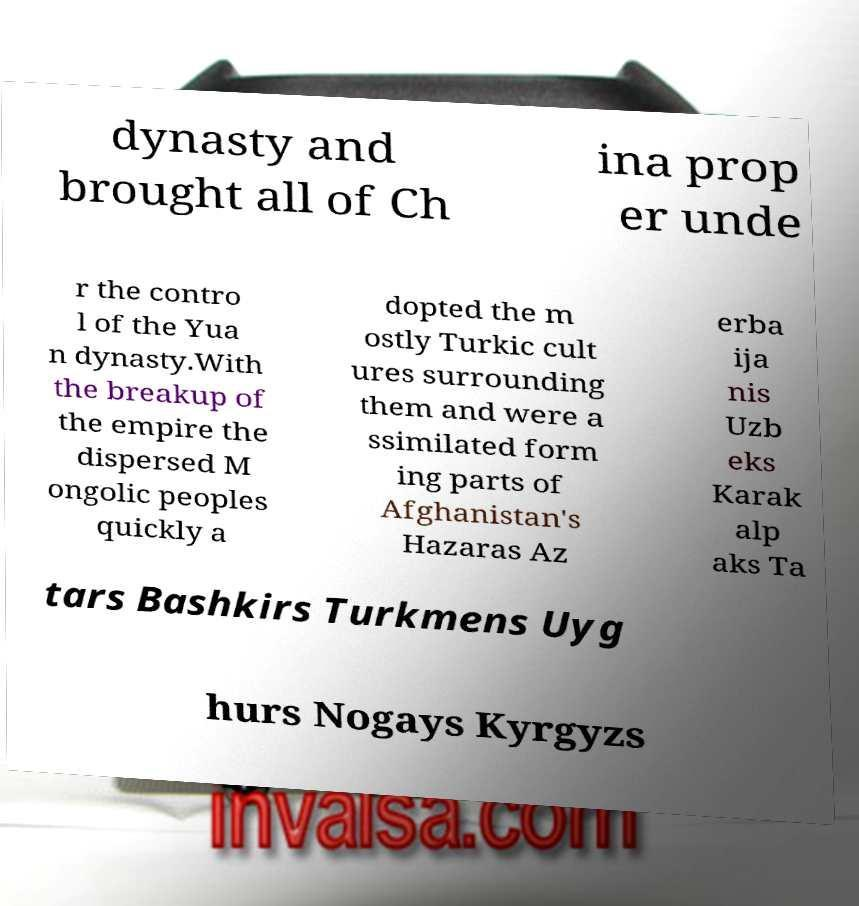Please identify and transcribe the text found in this image. dynasty and brought all of Ch ina prop er unde r the contro l of the Yua n dynasty.With the breakup of the empire the dispersed M ongolic peoples quickly a dopted the m ostly Turkic cult ures surrounding them and were a ssimilated form ing parts of Afghanistan's Hazaras Az erba ija nis Uzb eks Karak alp aks Ta tars Bashkirs Turkmens Uyg hurs Nogays Kyrgyzs 